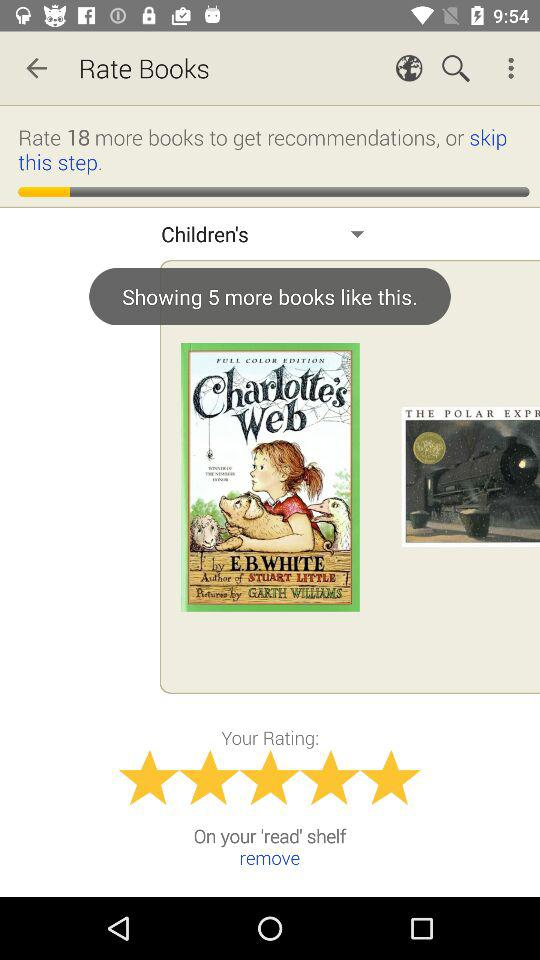What is the version of this application?
When the provided information is insufficient, respond with <no answer>. <no answer> 